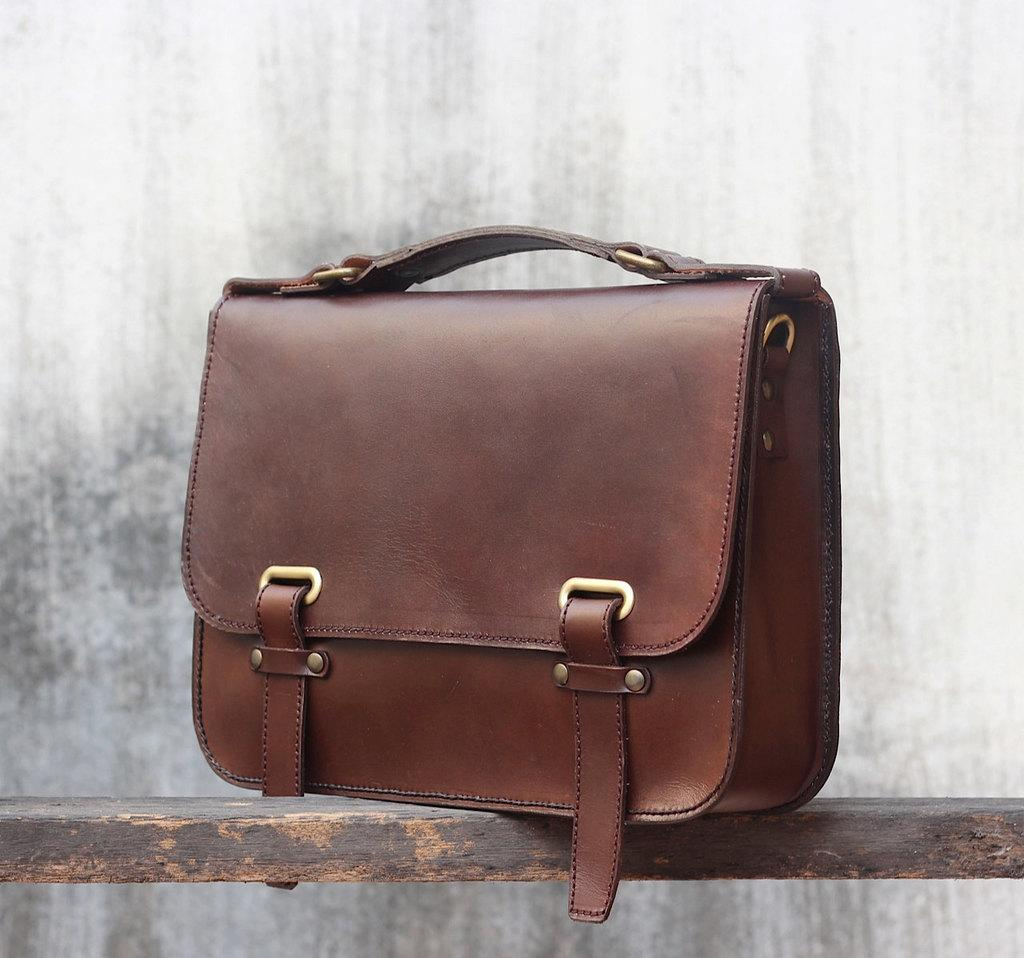What type of bag is visible in the image? There is a brown color leather bag in the image. Where is the leather bag placed in the image? The leather bag is kept on a wooden bench. Can you see any relations between the leather bag and the wooden bench in the image? There is no indication of a relation between the leather bag and the wooden bench in the image; they are simply placed next to each other. Is there a nest visible in the image? There is no nest present in the image. 